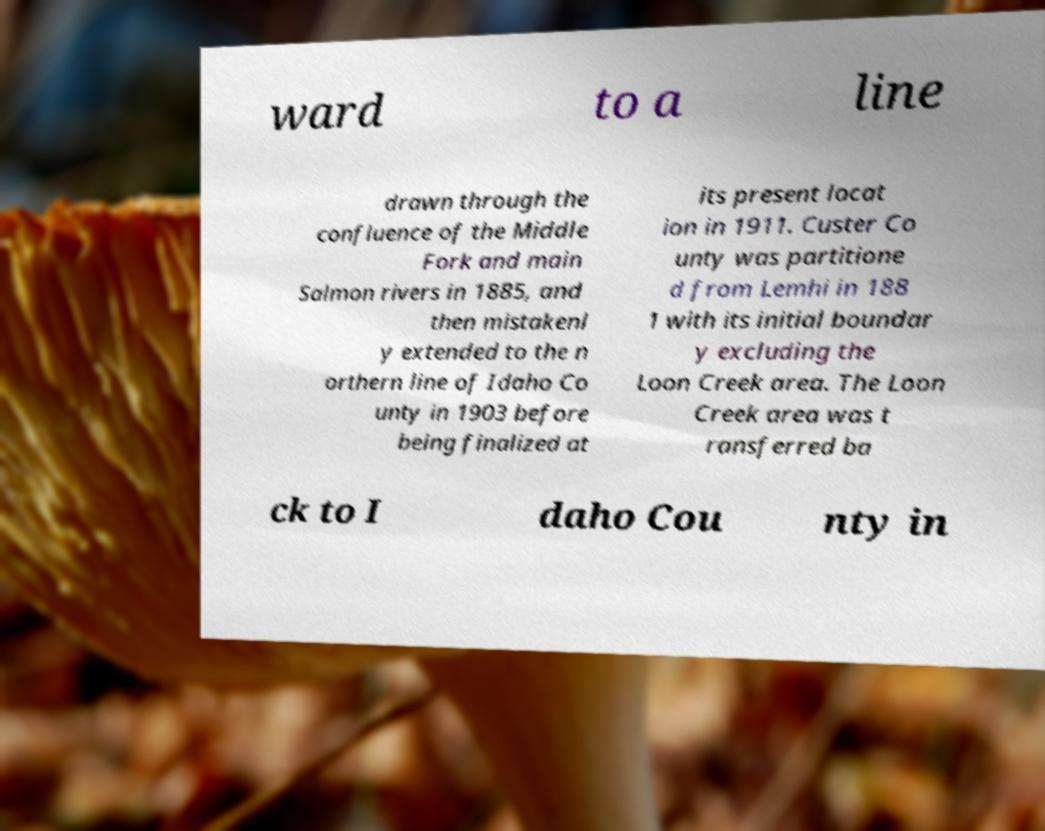Could you assist in decoding the text presented in this image and type it out clearly? ward to a line drawn through the confluence of the Middle Fork and main Salmon rivers in 1885, and then mistakenl y extended to the n orthern line of Idaho Co unty in 1903 before being finalized at its present locat ion in 1911. Custer Co unty was partitione d from Lemhi in 188 1 with its initial boundar y excluding the Loon Creek area. The Loon Creek area was t ransferred ba ck to I daho Cou nty in 